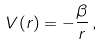<formula> <loc_0><loc_0><loc_500><loc_500>V ( r ) = - \frac { \beta } { r } \, ,</formula> 